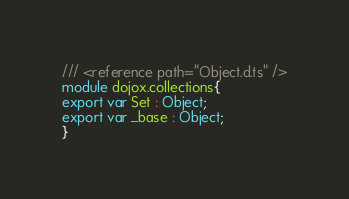Convert code to text. <code><loc_0><loc_0><loc_500><loc_500><_TypeScript_>/// <reference path="Object.d.ts" />
module dojox.collections{
export var Set : Object;
export var _base : Object;
}
</code> 